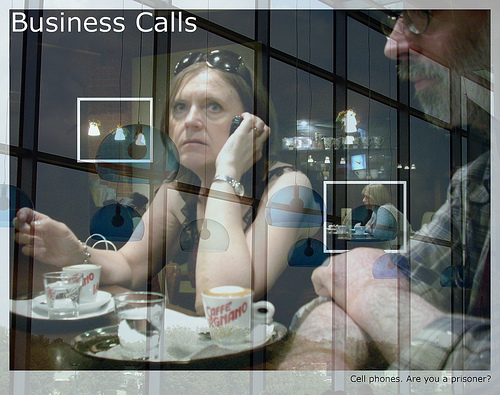Is the plate to the right or to the left of the man that is wearing glasses? The plate is to the left of the man who is wearing glasses. 